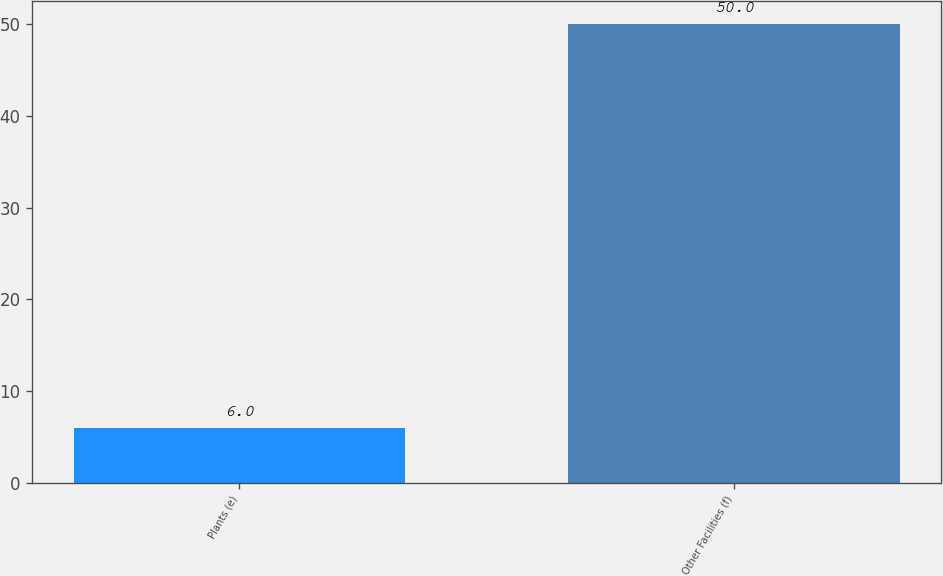Convert chart. <chart><loc_0><loc_0><loc_500><loc_500><bar_chart><fcel>Plants (e)<fcel>Other Facilities (f)<nl><fcel>6<fcel>50<nl></chart> 